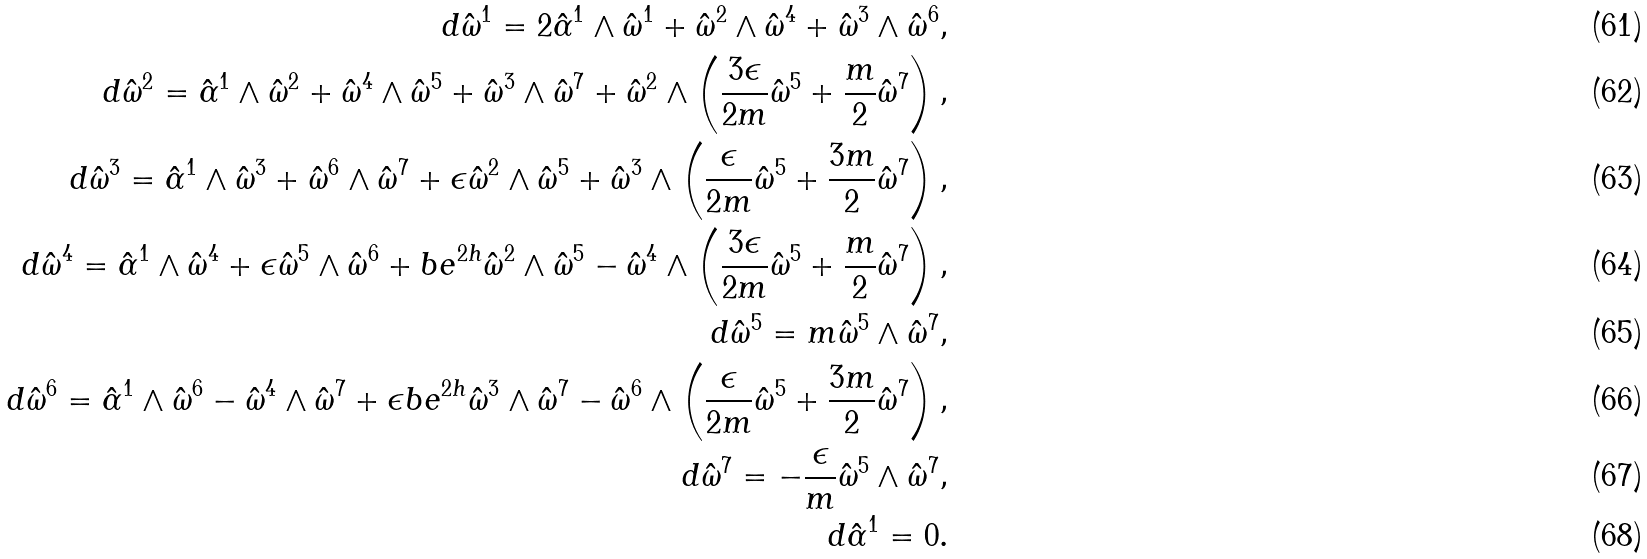<formula> <loc_0><loc_0><loc_500><loc_500>d \hat { \omega } ^ { 1 } = 2 \hat { \alpha } ^ { 1 } \wedge \hat { \omega } ^ { 1 } + \hat { \omega } ^ { 2 } \wedge \hat { \omega } ^ { 4 } + \hat { \omega } ^ { 3 } \wedge \hat { \omega } ^ { 6 } , \\ d \hat { \omega } ^ { 2 } = \hat { \alpha } ^ { 1 } \wedge \hat { \omega } ^ { 2 } + \hat { \omega } ^ { 4 } \wedge \hat { \omega } ^ { 5 } + \hat { \omega } ^ { 3 } \wedge \hat { \omega } ^ { 7 } + \hat { \omega } ^ { 2 } \wedge \left ( \frac { 3 \epsilon } { 2 m } \hat { \omega } ^ { 5 } + \frac { m } { 2 } \hat { \omega } ^ { 7 } \right ) , \\ d \hat { \omega } ^ { 3 } = \hat { \alpha } ^ { 1 } \wedge \hat { \omega } ^ { 3 } + \hat { \omega } ^ { 6 } \wedge \hat { \omega } ^ { 7 } + \epsilon \hat { \omega } ^ { 2 } \wedge \hat { \omega } ^ { 5 } + \hat { \omega } ^ { 3 } \wedge \left ( \frac { \epsilon } { 2 m } \hat { \omega } ^ { 5 } + \frac { 3 m } { 2 } \hat { \omega } ^ { 7 } \right ) , \\ d \hat { \omega } ^ { 4 } = \hat { \alpha } ^ { 1 } \wedge \hat { \omega } ^ { 4 } + \epsilon \hat { \omega } ^ { 5 } \wedge \hat { \omega } ^ { 6 } + b e ^ { 2 h } \hat { \omega } ^ { 2 } \wedge \hat { \omega } ^ { 5 } - \hat { \omega } ^ { 4 } \wedge \left ( \frac { 3 \epsilon } { 2 m } \hat { \omega } ^ { 5 } + \frac { m } { 2 } \hat { \omega } ^ { 7 } \right ) , \\ d \hat { \omega } ^ { 5 } = m \hat { \omega } ^ { 5 } \wedge \hat { \omega } ^ { 7 } , \\ d \hat { \omega } ^ { 6 } = \hat { \alpha } ^ { 1 } \wedge \hat { \omega } ^ { 6 } - \hat { \omega } ^ { 4 } \wedge \hat { \omega } ^ { 7 } + \epsilon b e ^ { 2 h } \hat { \omega } ^ { 3 } \wedge \hat { \omega } ^ { 7 } - \hat { \omega } ^ { 6 } \wedge \left ( \frac { \epsilon } { 2 m } \hat { \omega } ^ { 5 } + \frac { 3 m } { 2 } \hat { \omega } ^ { 7 } \right ) , \\ d \hat { \omega } ^ { 7 } = - \frac { \epsilon } { m } \hat { \omega } ^ { 5 } \wedge \hat { \omega } ^ { 7 } , \\ d \hat { \alpha } ^ { 1 } = 0 .</formula> 